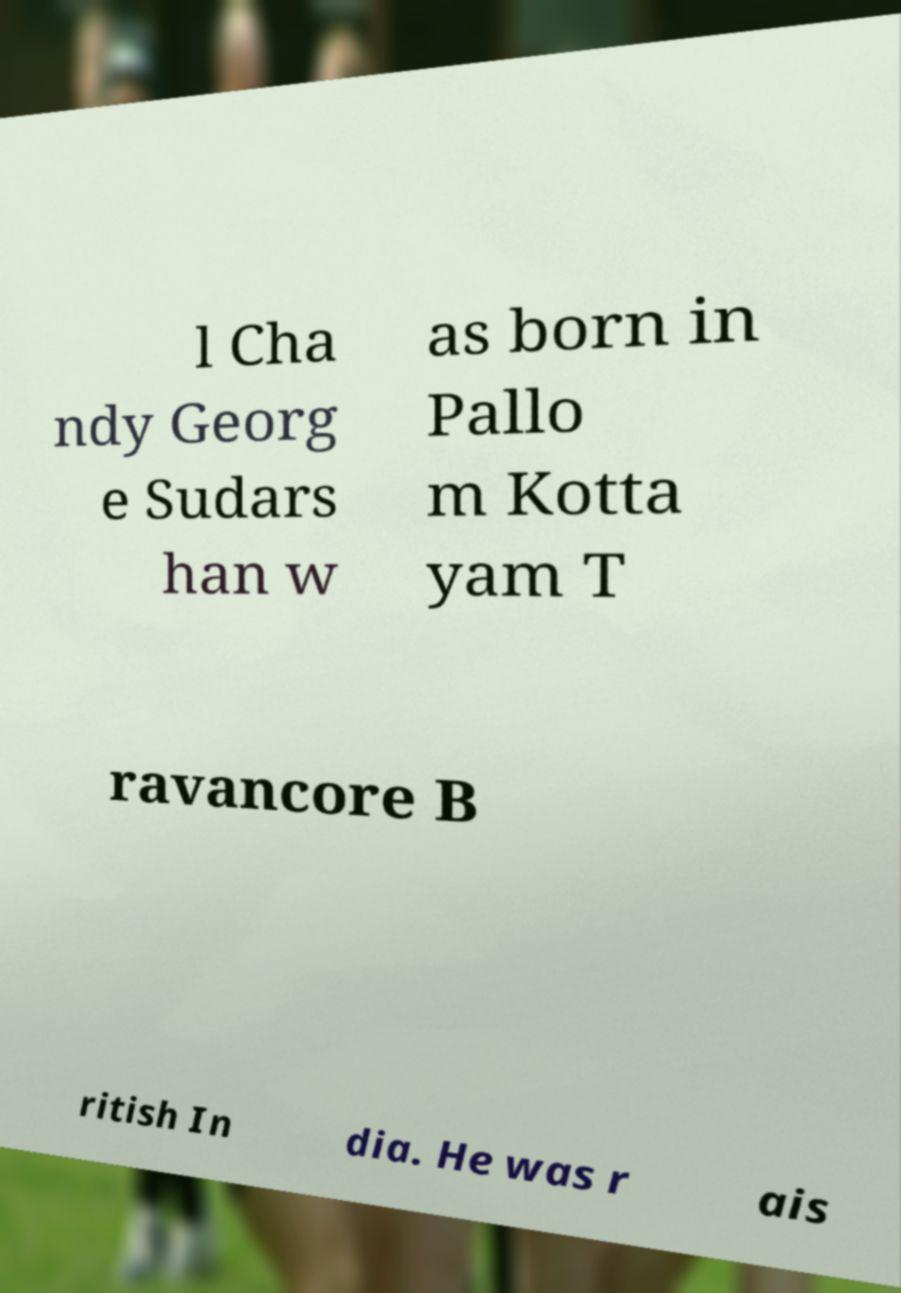I need the written content from this picture converted into text. Can you do that? l Cha ndy Georg e Sudars han w as born in Pallo m Kotta yam T ravancore B ritish In dia. He was r ais 